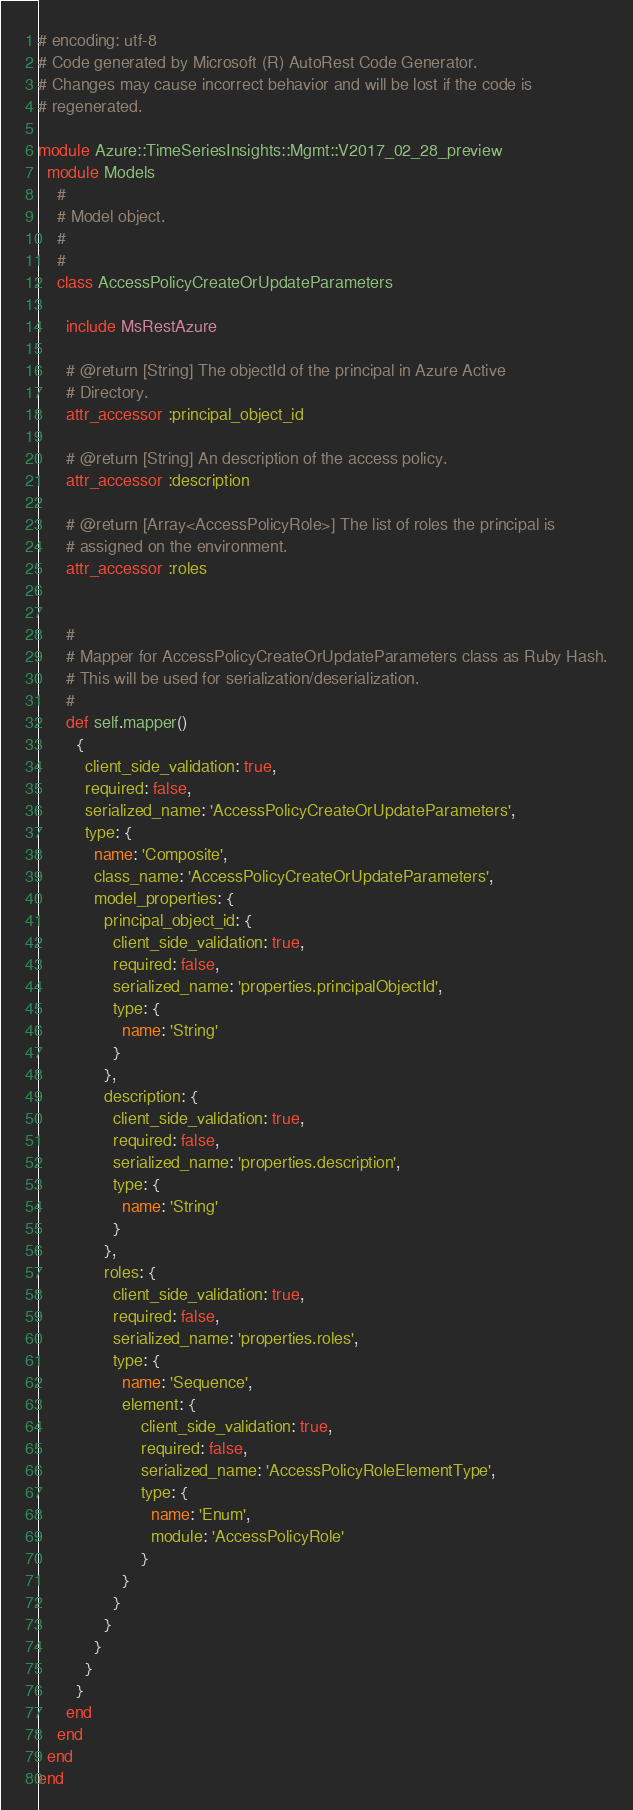Convert code to text. <code><loc_0><loc_0><loc_500><loc_500><_Ruby_># encoding: utf-8
# Code generated by Microsoft (R) AutoRest Code Generator.
# Changes may cause incorrect behavior and will be lost if the code is
# regenerated.

module Azure::TimeSeriesInsights::Mgmt::V2017_02_28_preview
  module Models
    #
    # Model object.
    #
    #
    class AccessPolicyCreateOrUpdateParameters

      include MsRestAzure

      # @return [String] The objectId of the principal in Azure Active
      # Directory.
      attr_accessor :principal_object_id

      # @return [String] An description of the access policy.
      attr_accessor :description

      # @return [Array<AccessPolicyRole>] The list of roles the principal is
      # assigned on the environment.
      attr_accessor :roles


      #
      # Mapper for AccessPolicyCreateOrUpdateParameters class as Ruby Hash.
      # This will be used for serialization/deserialization.
      #
      def self.mapper()
        {
          client_side_validation: true,
          required: false,
          serialized_name: 'AccessPolicyCreateOrUpdateParameters',
          type: {
            name: 'Composite',
            class_name: 'AccessPolicyCreateOrUpdateParameters',
            model_properties: {
              principal_object_id: {
                client_side_validation: true,
                required: false,
                serialized_name: 'properties.principalObjectId',
                type: {
                  name: 'String'
                }
              },
              description: {
                client_side_validation: true,
                required: false,
                serialized_name: 'properties.description',
                type: {
                  name: 'String'
                }
              },
              roles: {
                client_side_validation: true,
                required: false,
                serialized_name: 'properties.roles',
                type: {
                  name: 'Sequence',
                  element: {
                      client_side_validation: true,
                      required: false,
                      serialized_name: 'AccessPolicyRoleElementType',
                      type: {
                        name: 'Enum',
                        module: 'AccessPolicyRole'
                      }
                  }
                }
              }
            }
          }
        }
      end
    end
  end
end
</code> 